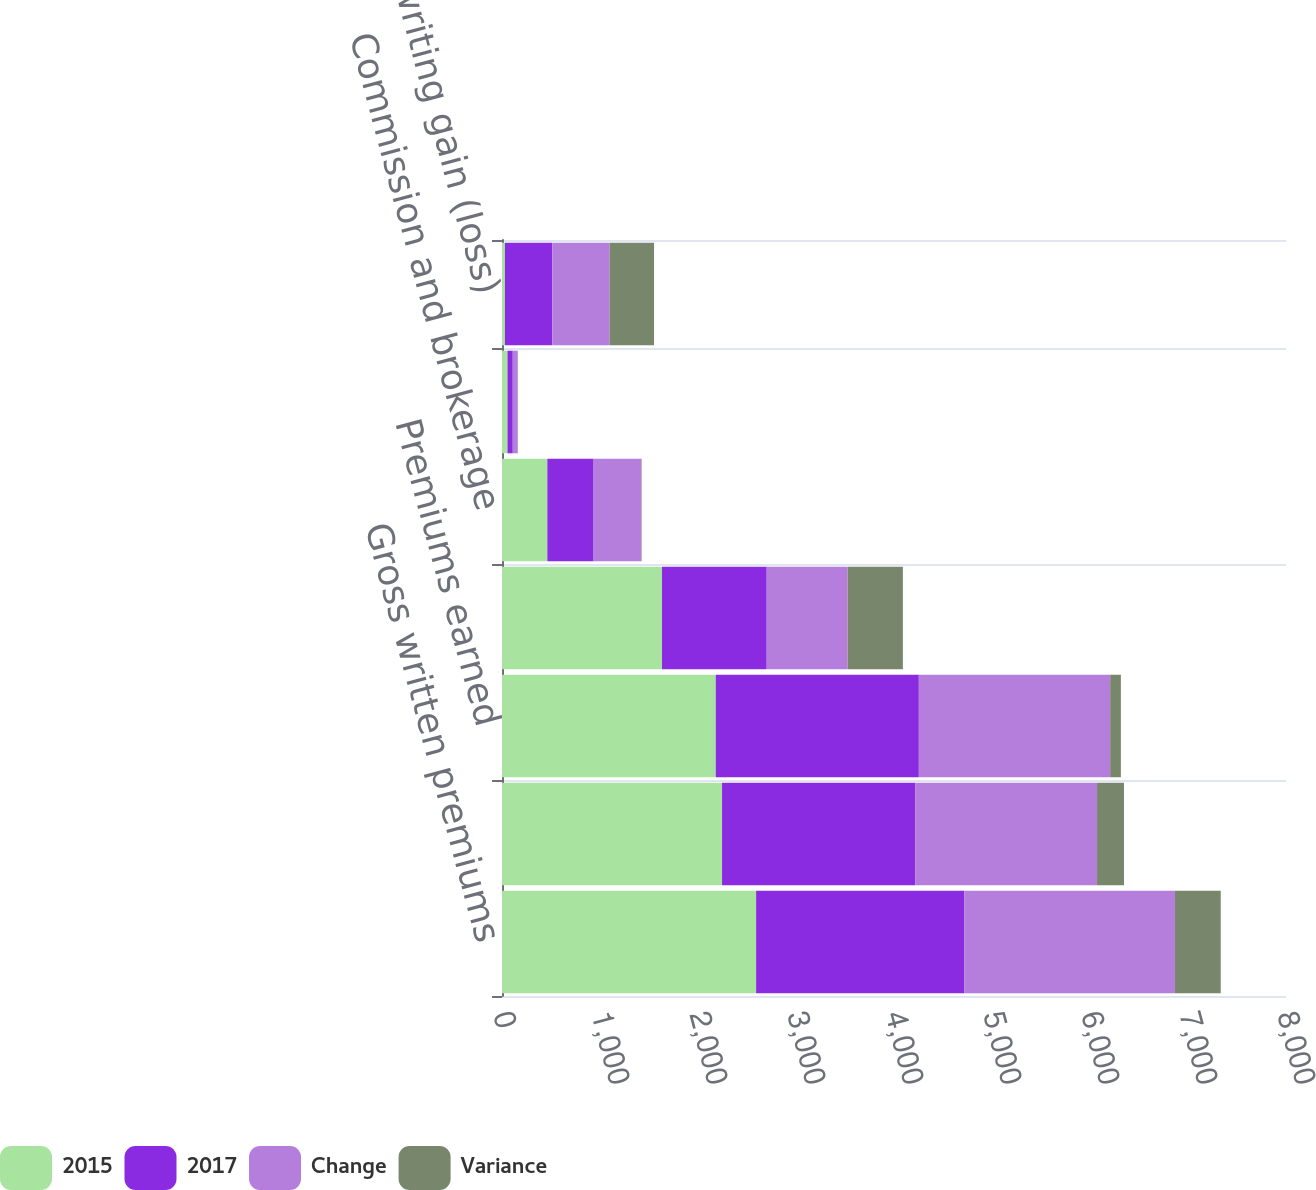Convert chart to OTSL. <chart><loc_0><loc_0><loc_500><loc_500><stacked_bar_chart><ecel><fcel>Gross written premiums<fcel>Net written premiums<fcel>Premiums earned<fcel>Incurred losses and LAE<fcel>Commission and brokerage<fcel>Other underwriting expenses<fcel>Underwriting gain (loss)<nl><fcel>2015<fcel>2593<fcel>2245.4<fcel>2181.2<fcel>1632.8<fcel>462.5<fcel>55.9<fcel>30<nl><fcel>2017<fcel>2125.8<fcel>1970.6<fcel>2072.2<fcel>1068.5<fcel>466<fcel>54.1<fcel>483.6<nl><fcel>Change<fcel>2147.9<fcel>1855.9<fcel>1952.7<fcel>825.1<fcel>493.3<fcel>50.1<fcel>584.3<nl><fcel>Variance<fcel>467.2<fcel>274.8<fcel>109<fcel>564.3<fcel>3.5<fcel>1.8<fcel>453.6<nl></chart> 